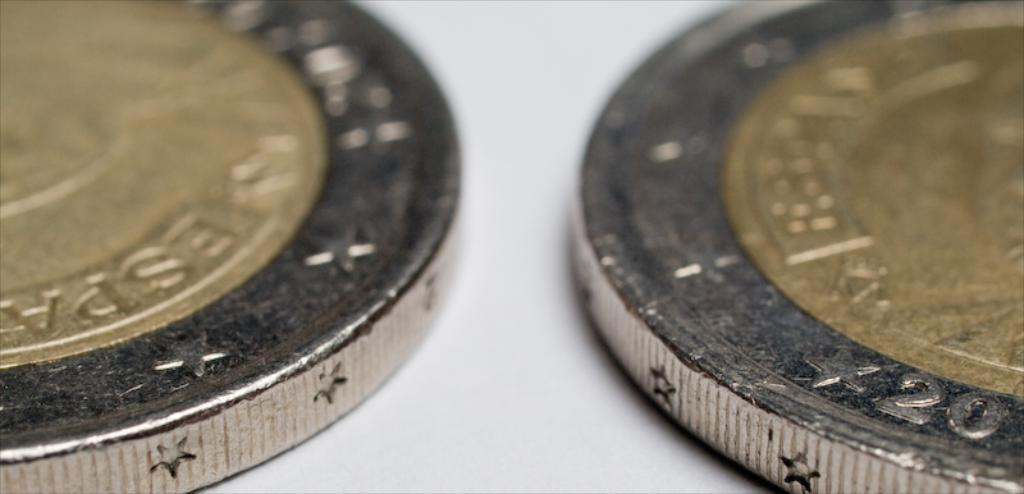<image>
Summarize the visual content of the image. Two two-toned metal coins that appear to be from Espana, on one the number 20 can be seen. 